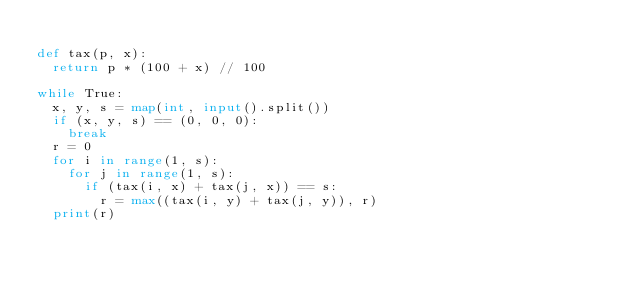<code> <loc_0><loc_0><loc_500><loc_500><_Python_>
def tax(p, x):
	return p * (100 + x) // 100

while True:
	x, y, s = map(int, input().split())
	if (x, y, s) == (0, 0, 0):
		break
	r = 0
	for i in range(1, s):
		for j in range(1, s):
			if (tax(i, x) + tax(j, x)) == s:
				r = max((tax(i, y) + tax(j, y)), r)
	print(r)</code> 